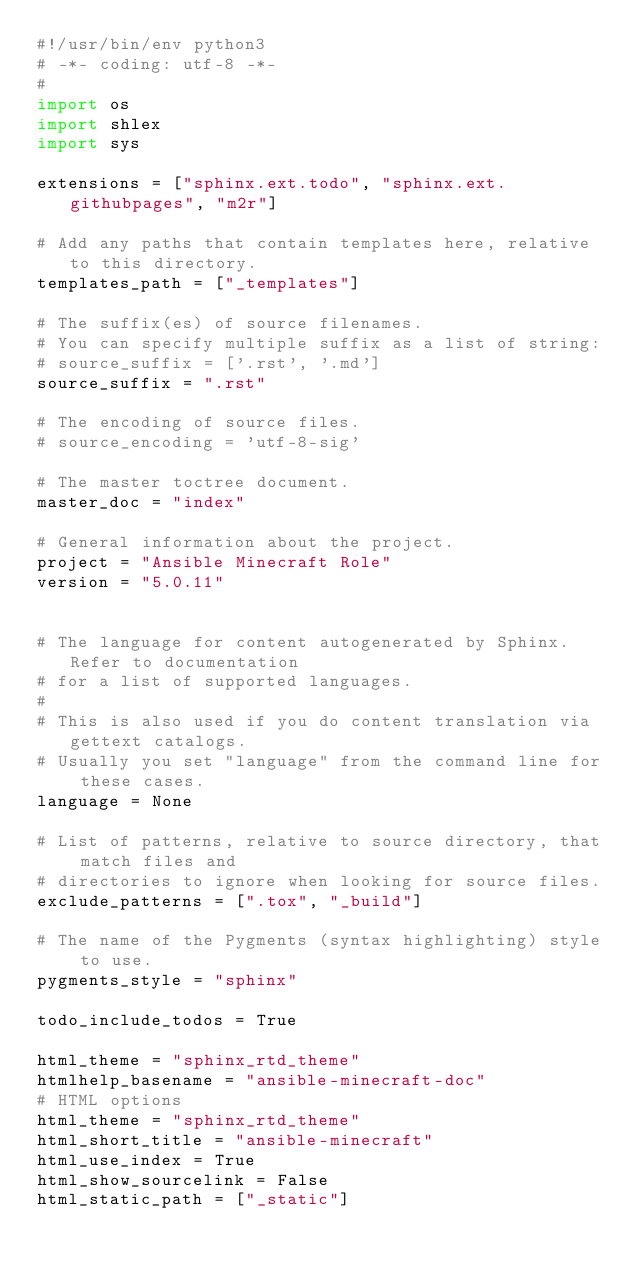<code> <loc_0><loc_0><loc_500><loc_500><_Python_>#!/usr/bin/env python3
# -*- coding: utf-8 -*-
#
import os
import shlex
import sys

extensions = ["sphinx.ext.todo", "sphinx.ext.githubpages", "m2r"]

# Add any paths that contain templates here, relative to this directory.
templates_path = ["_templates"]

# The suffix(es) of source filenames.
# You can specify multiple suffix as a list of string:
# source_suffix = ['.rst', '.md']
source_suffix = ".rst"

# The encoding of source files.
# source_encoding = 'utf-8-sig'

# The master toctree document.
master_doc = "index"

# General information about the project.
project = "Ansible Minecraft Role"
version = "5.0.11"


# The language for content autogenerated by Sphinx. Refer to documentation
# for a list of supported languages.
#
# This is also used if you do content translation via gettext catalogs.
# Usually you set "language" from the command line for these cases.
language = None

# List of patterns, relative to source directory, that match files and
# directories to ignore when looking for source files.
exclude_patterns = [".tox", "_build"]

# The name of the Pygments (syntax highlighting) style to use.
pygments_style = "sphinx"

todo_include_todos = True

html_theme = "sphinx_rtd_theme"
htmlhelp_basename = "ansible-minecraft-doc"
# HTML options
html_theme = "sphinx_rtd_theme"
html_short_title = "ansible-minecraft"
html_use_index = True
html_show_sourcelink = False
html_static_path = ["_static"]
</code> 